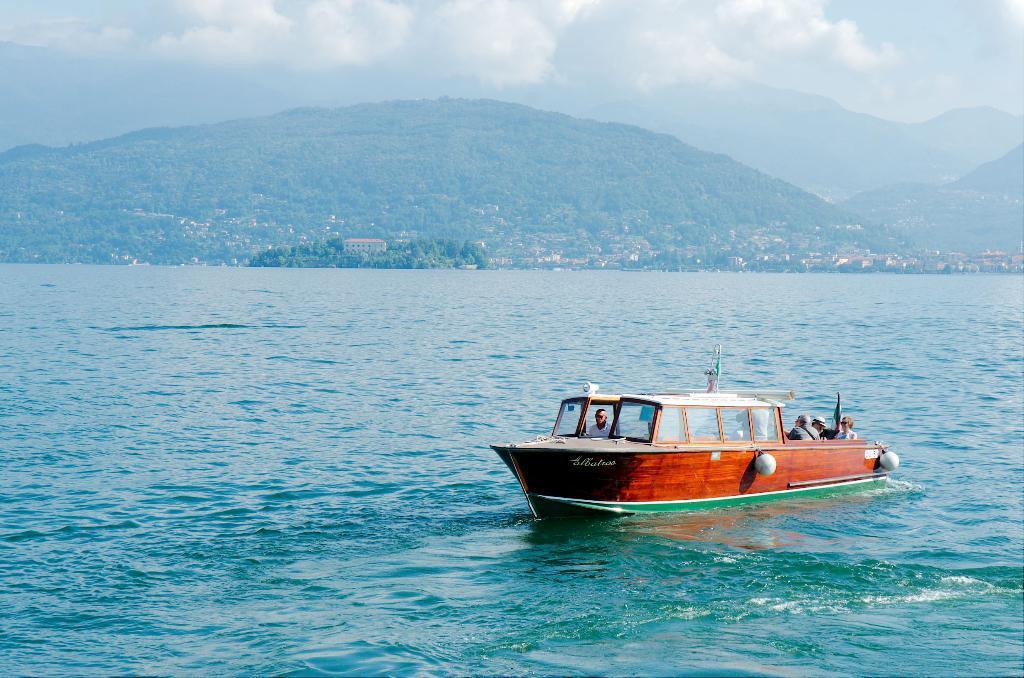Could you give a brief overview of what you see in this image? There is a boat on the water. Here we can see few people on the boat. In the background there are houses, trees, mountain, and sky with clouds. 